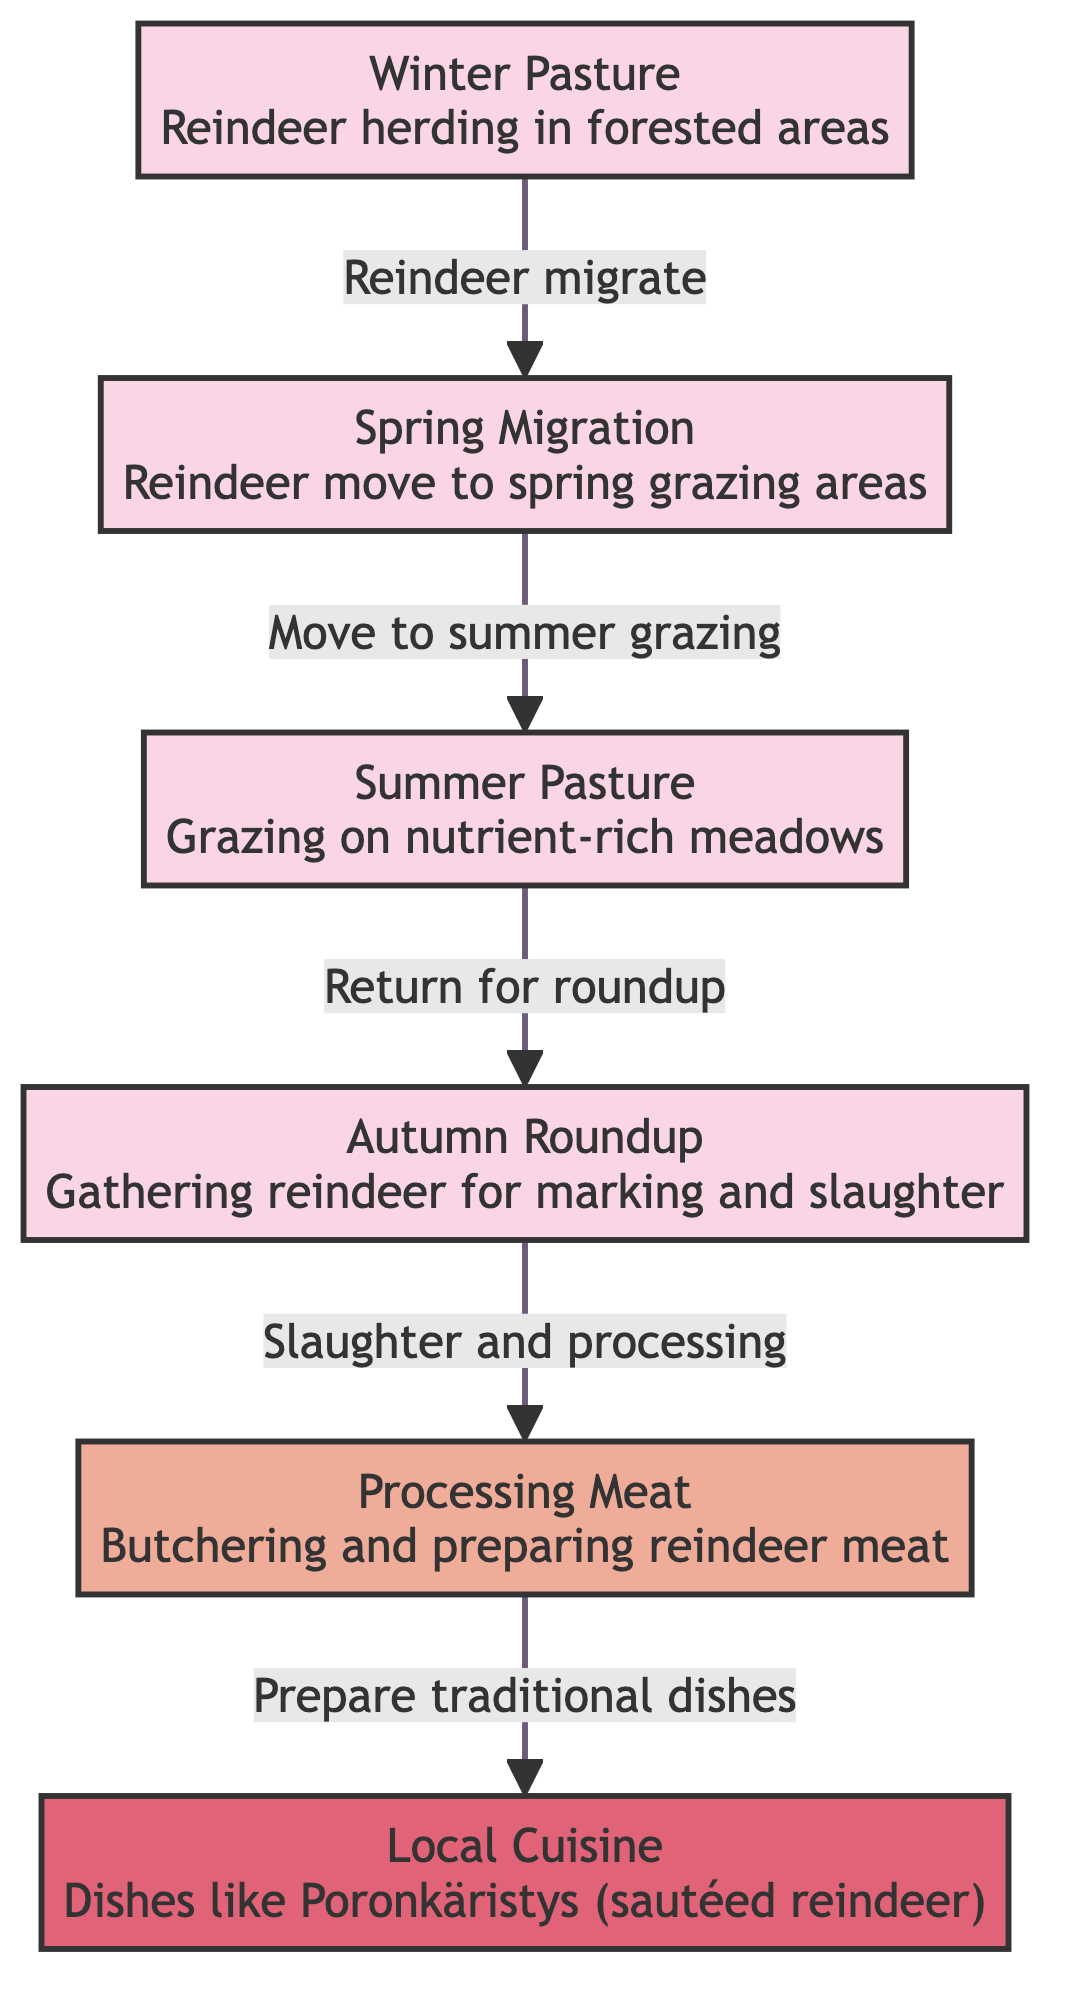What is the first season mentioned in the diagram? The diagram begins with the "Winter Pasture" node, which is the first seasonal stage of the reindeer herding cycle.
Answer: Winter Pasture How many seasonal stages are there in total? There are four seasonal stages depicted in the flowchart: Winter Pasture, Spring Migration, Summer Pasture, and Autumn Roundup.
Answer: 4 What process follows the Autumn Roundup? After the Autumn Roundup, the next step in the diagram is "Processing Meat," which involves butchering and preparing the reindeer meat.
Answer: Processing Meat Which dish is specifically mentioned in relation to local cuisine? The diagram states "Poronkäristys," which is a traditional dish made with sautéed reindeer.
Answer: Poronkäristys What is the relationship between Summer Pasture and Autumn Roundup? The diagram shows that from Summer Pasture, reindeer migrate back to gather for Autumn Roundup, indicating a connection of movement from grazing to gathering.
Answer: Return for roundup Which two activities occur as part of the herding cycle before local cuisine is prepared? The steps before local cuisine preparation include "Processing Meat" and "Autumn Roundup," which involves gathering the reindeer for meat processing.
Answer: Autumn Roundup and Processing Meat Describe the flow from Spring Migration to Summer Pasture. The diagram indicates that after Spring Migration, the reindeer move to Summer Pasture for grazing on nutrient-rich meadows, showing a progression in the seasonal herding cycle.
Answer: Move to summer grazing What kind of herding activities occur during Winter? The diagram indicates that during Winter, reindeer herding takes place in forested areas, specifically noted as "Winter Pasture."
Answer: Winter Pasture 